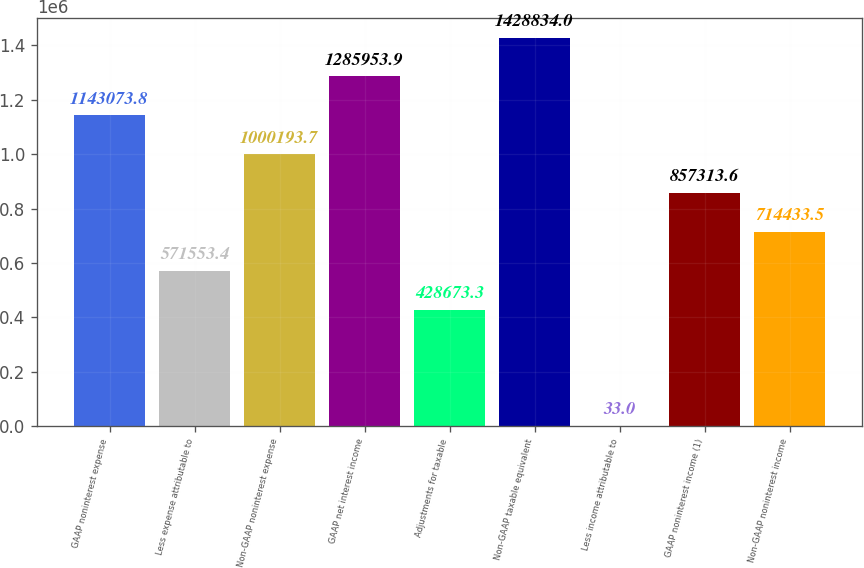<chart> <loc_0><loc_0><loc_500><loc_500><bar_chart><fcel>GAAP noninterest expense<fcel>Less expense attributable to<fcel>Non-GAAP noninterest expense<fcel>GAAP net interest income<fcel>Adjustments for taxable<fcel>Non-GAAP taxable equivalent<fcel>Less income attributable to<fcel>GAAP noninterest income (1)<fcel>Non-GAAP noninterest income<nl><fcel>1.14307e+06<fcel>571553<fcel>1.00019e+06<fcel>1.28595e+06<fcel>428673<fcel>1.42883e+06<fcel>33<fcel>857314<fcel>714434<nl></chart> 